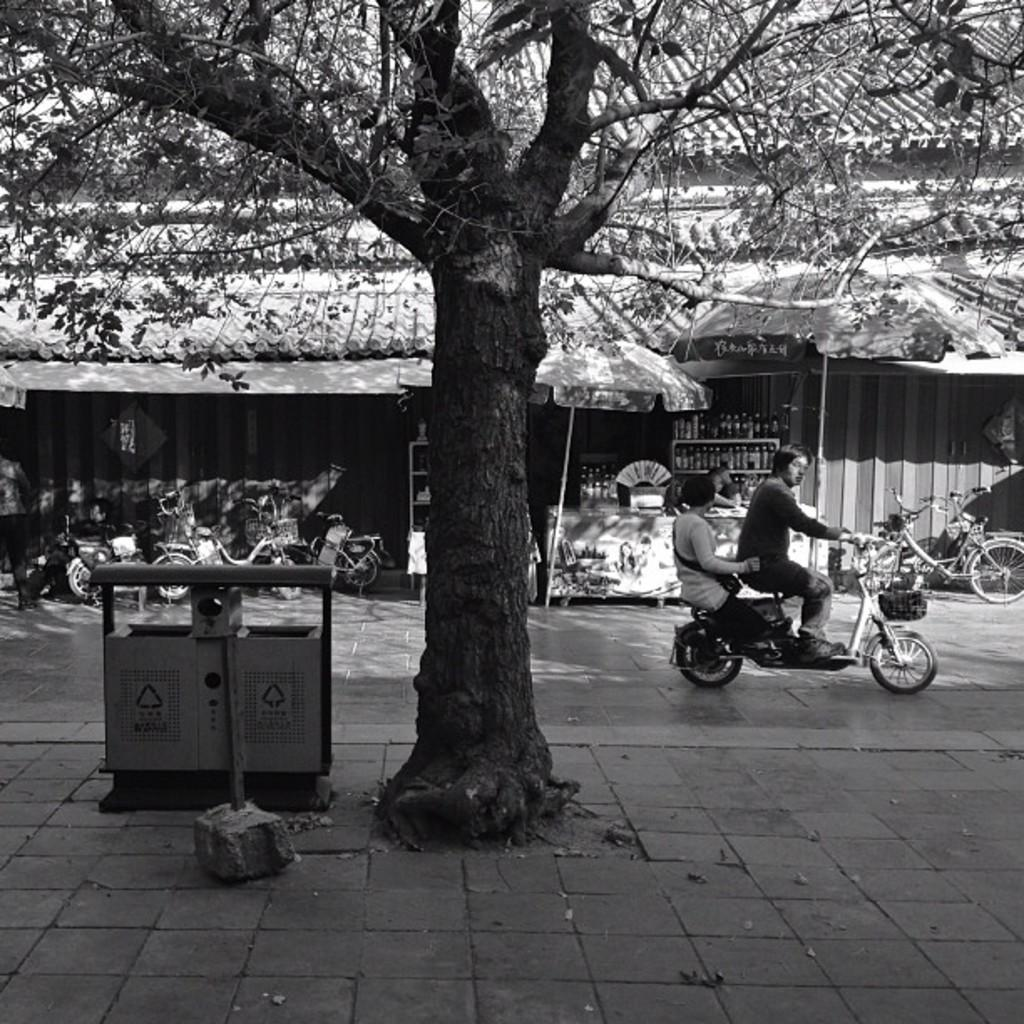What can be seen on the side of the road in the image? There is a tree on the side of the road in the image. How many people are in the vehicle in the image? There are two people in a vehicle in the image. Are there any parked vehicles in the image? Yes, there are vehicles parked in the image. What is visible in the background of the image? There is a building in the background of the image. What type of thread is being used to hold up the structure in the image? There is no structure or thread present in the image; it features a tree, vehicles, and a building. What kind of bait is being used to attract fish in the image? There is no fishing or bait present in the image. 